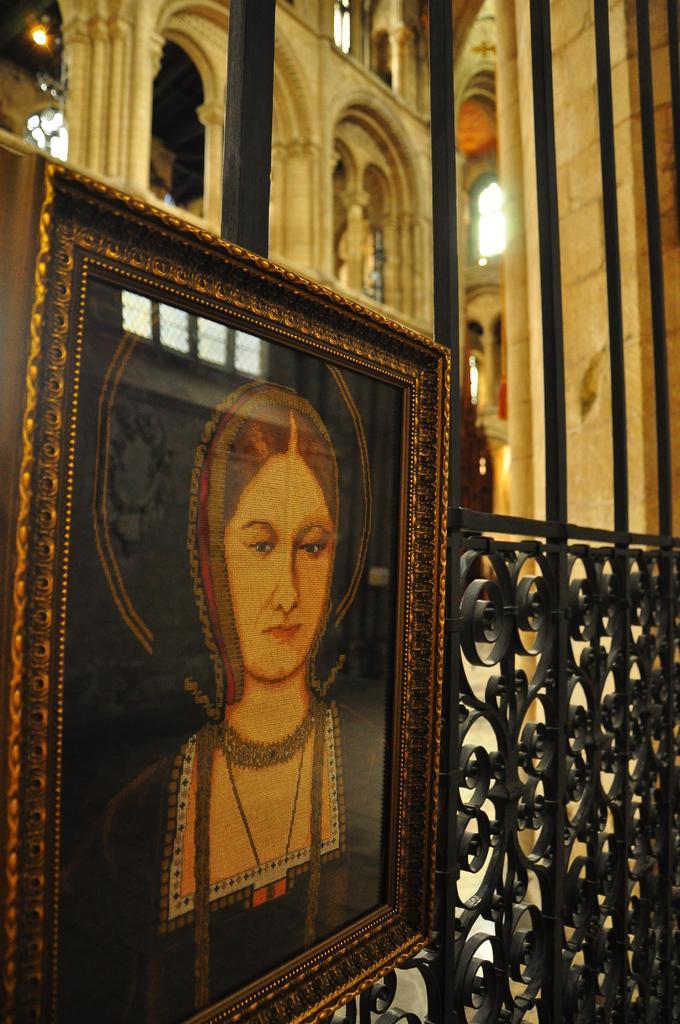Can you describe this image briefly? In this image we can see a photo frame on the railing and in the background, we can see a building. 